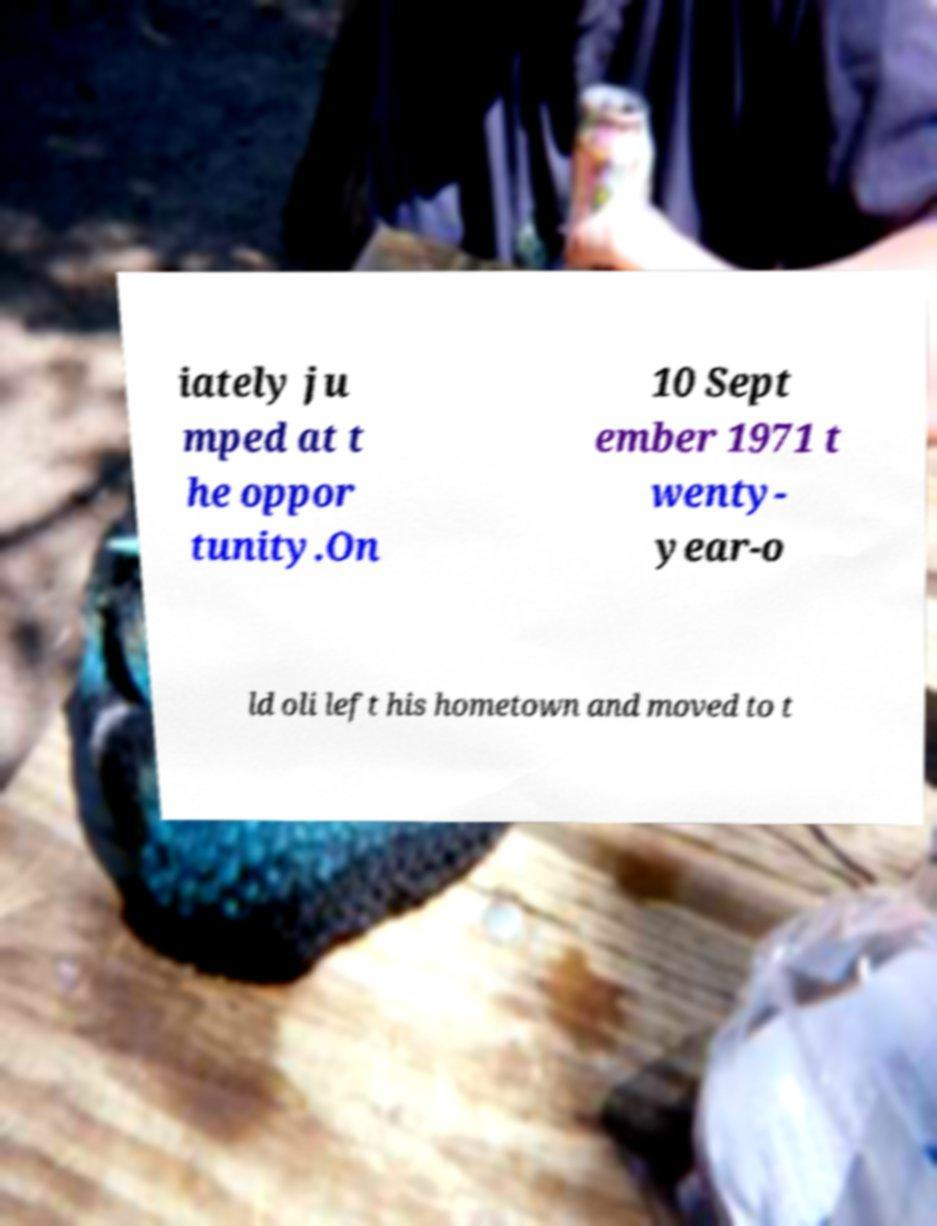There's text embedded in this image that I need extracted. Can you transcribe it verbatim? iately ju mped at t he oppor tunity.On 10 Sept ember 1971 t wenty- year-o ld oli left his hometown and moved to t 